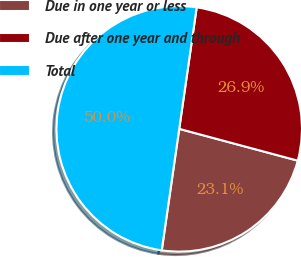Convert chart to OTSL. <chart><loc_0><loc_0><loc_500><loc_500><pie_chart><fcel>Due in one year or less<fcel>Due after one year and through<fcel>Total<nl><fcel>23.1%<fcel>26.9%<fcel>50.0%<nl></chart> 